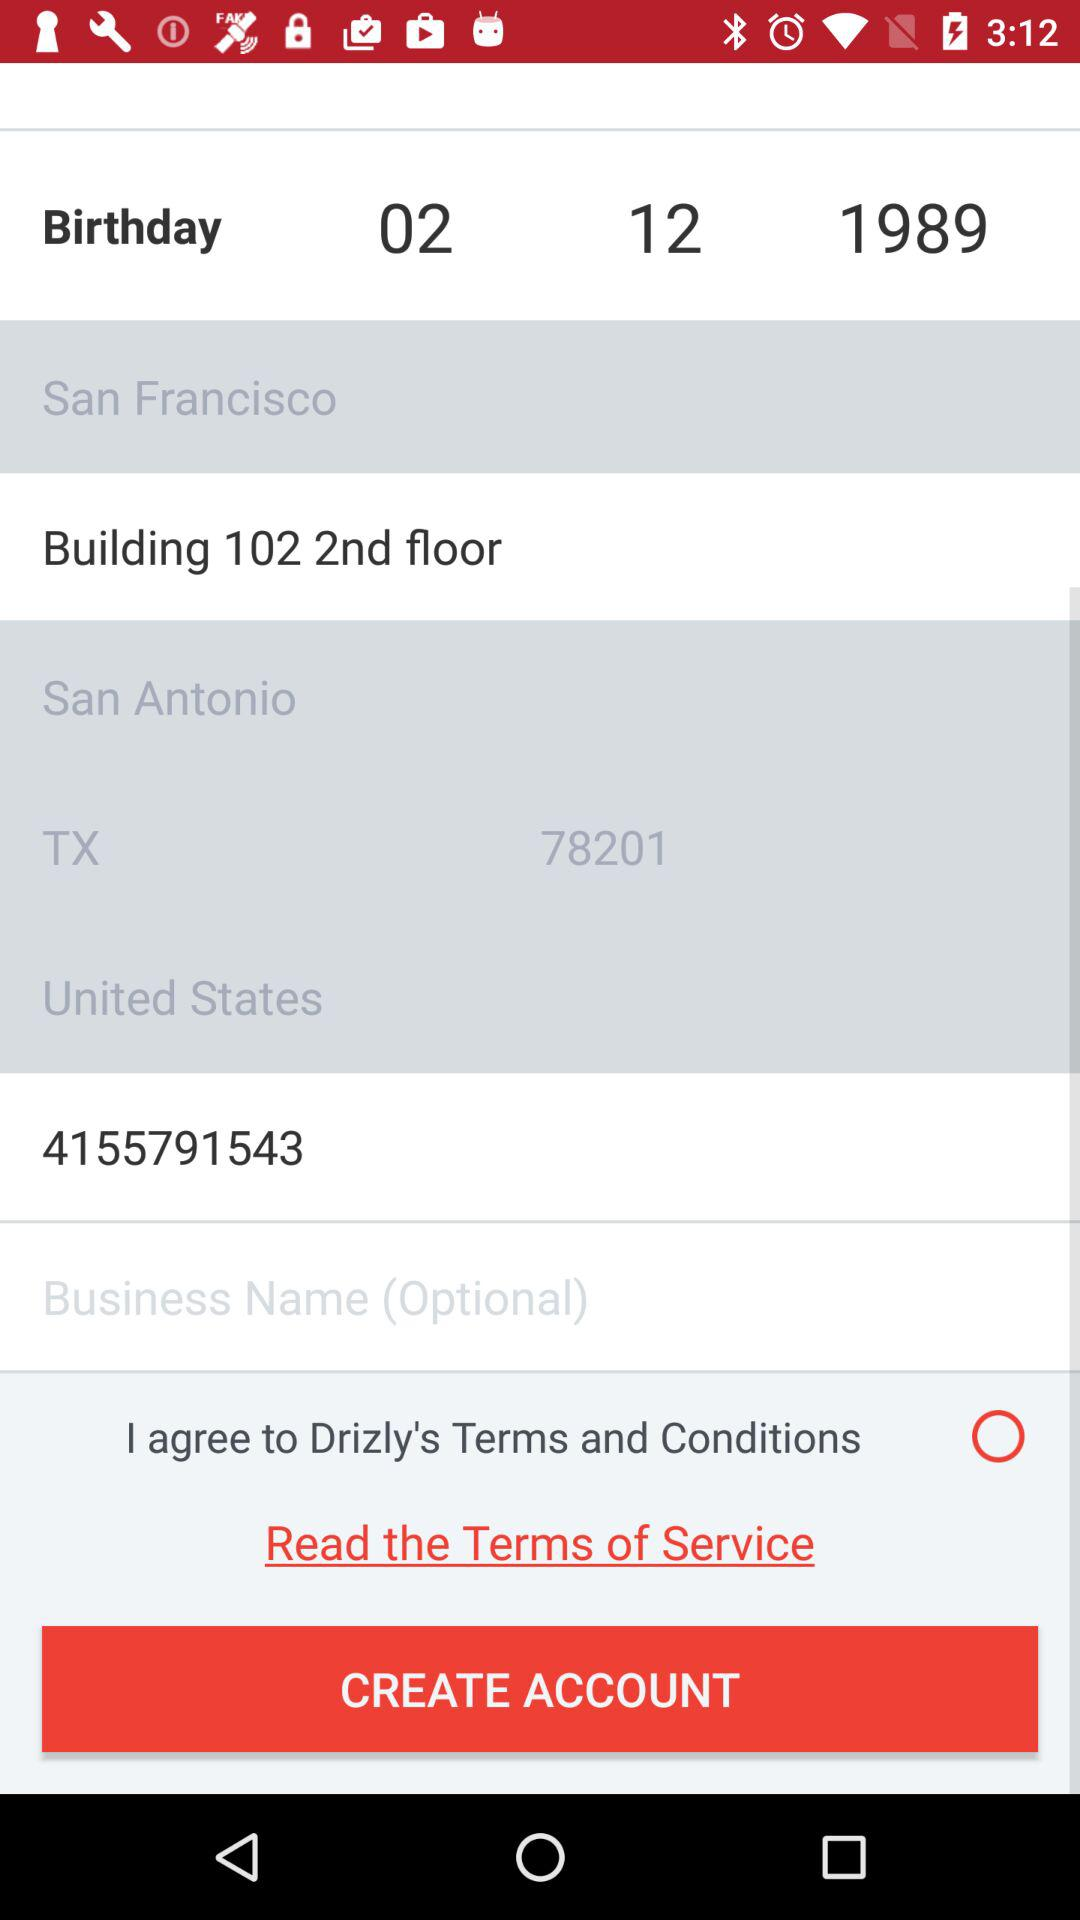What is the location? The locations are San Francisco and Building 102, 2nd floor, San Antonio, TX 78201, United States. 